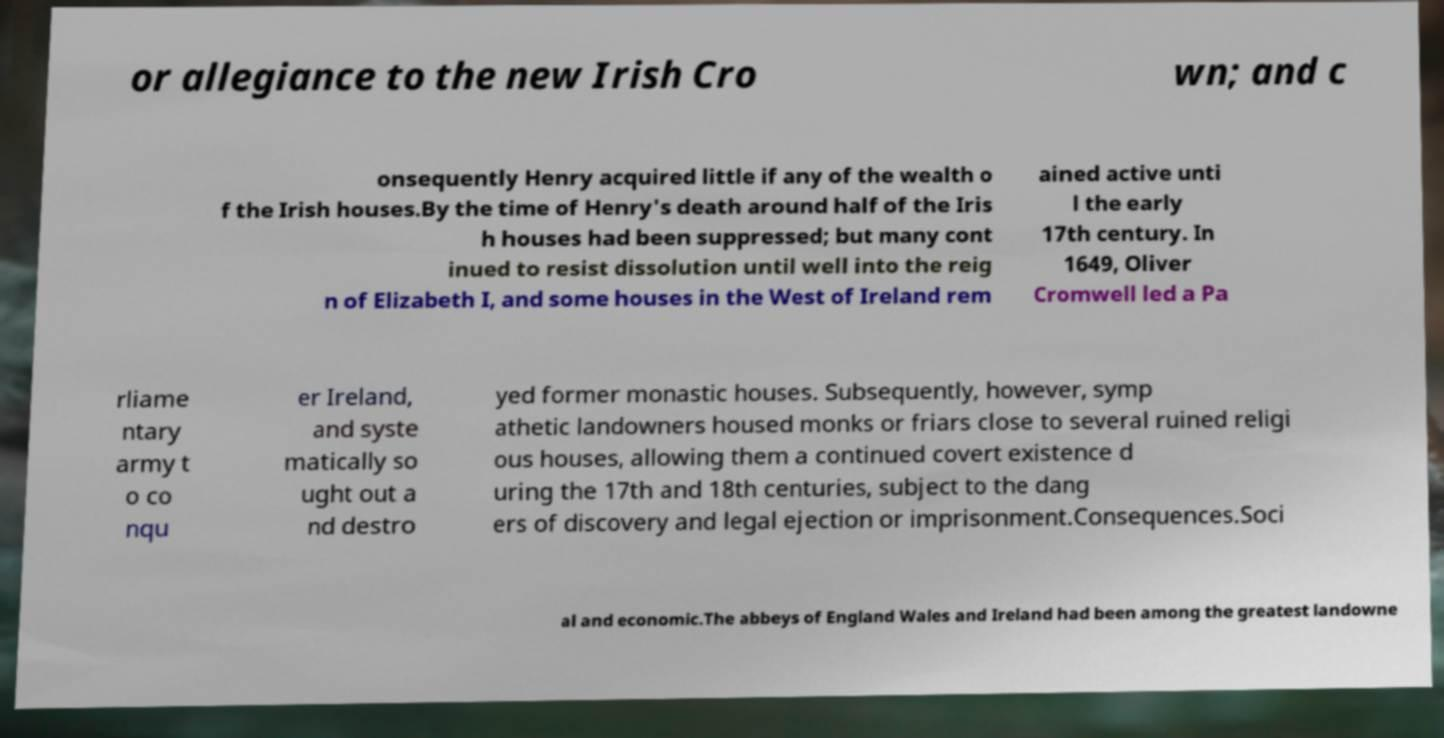Could you extract and type out the text from this image? or allegiance to the new Irish Cro wn; and c onsequently Henry acquired little if any of the wealth o f the Irish houses.By the time of Henry's death around half of the Iris h houses had been suppressed; but many cont inued to resist dissolution until well into the reig n of Elizabeth I, and some houses in the West of Ireland rem ained active unti l the early 17th century. In 1649, Oliver Cromwell led a Pa rliame ntary army t o co nqu er Ireland, and syste matically so ught out a nd destro yed former monastic houses. Subsequently, however, symp athetic landowners housed monks or friars close to several ruined religi ous houses, allowing them a continued covert existence d uring the 17th and 18th centuries, subject to the dang ers of discovery and legal ejection or imprisonment.Consequences.Soci al and economic.The abbeys of England Wales and Ireland had been among the greatest landowne 